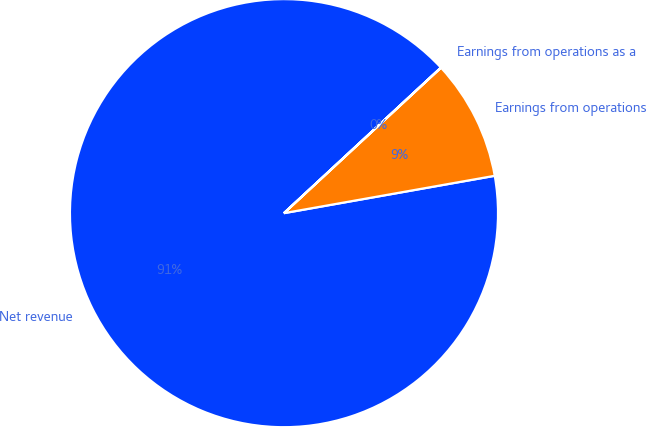Convert chart. <chart><loc_0><loc_0><loc_500><loc_500><pie_chart><fcel>Net revenue<fcel>Earnings from operations<fcel>Earnings from operations as a<nl><fcel>90.89%<fcel>9.1%<fcel>0.01%<nl></chart> 